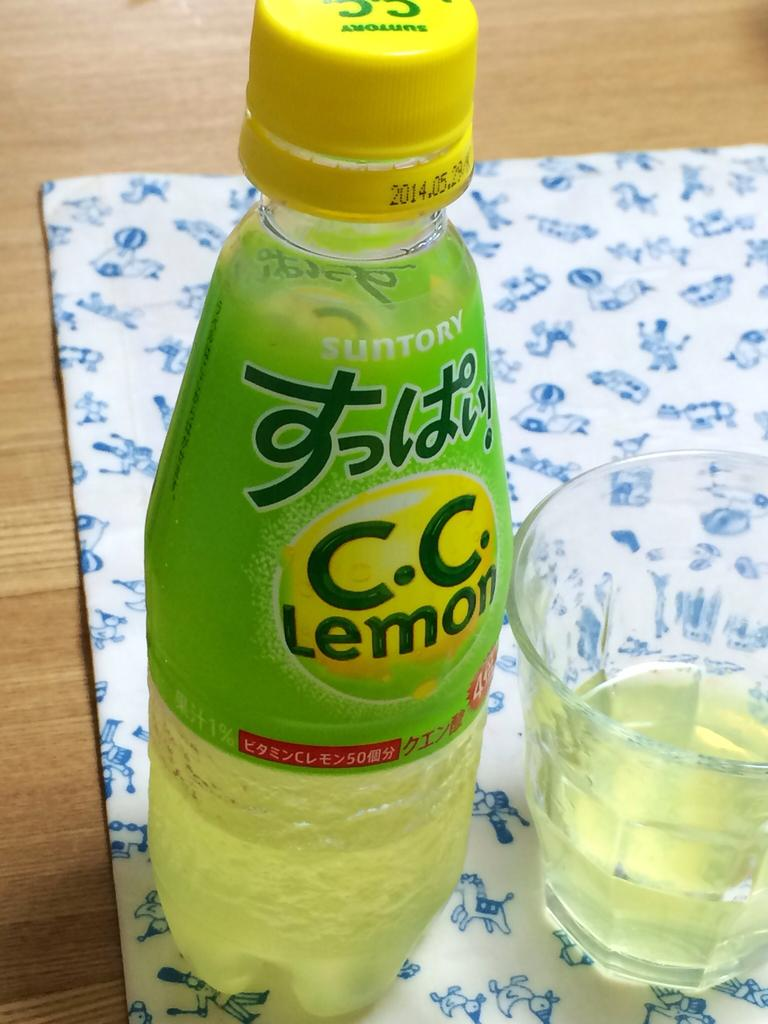<image>
Summarize the visual content of the image. a glass and bottle of CC Lemon drink with Japanese writing on it 